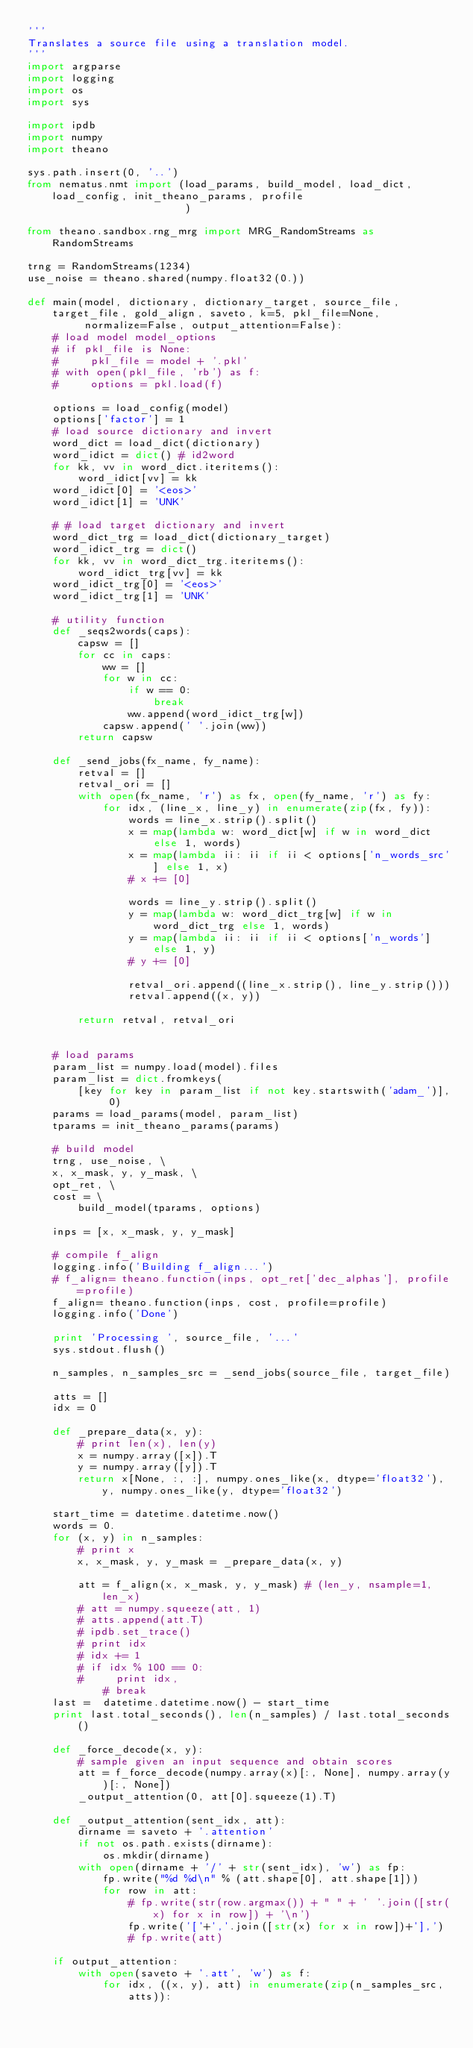Convert code to text. <code><loc_0><loc_0><loc_500><loc_500><_Python_>'''
Translates a source file using a translation model.
'''
import argparse
import logging
import os
import sys

import ipdb
import numpy
import theano

sys.path.insert(0, '..')
from nematus.nmt import (load_params, build_model, load_dict, load_config, init_theano_params, profile
                         )

from theano.sandbox.rng_mrg import MRG_RandomStreams as RandomStreams

trng = RandomStreams(1234)
use_noise = theano.shared(numpy.float32(0.))

def main(model, dictionary, dictionary_target, source_file, target_file, gold_align, saveto, k=5, pkl_file=None,
         normalize=False, output_attention=False):
    # load model model_options
    # if pkl_file is None:
    #     pkl_file = model + '.pkl'
    # with open(pkl_file, 'rb') as f:
    #     options = pkl.load(f)

    options = load_config(model)
    options['factor'] = 1
    # load source dictionary and invert
    word_dict = load_dict(dictionary)
    word_idict = dict() # id2word
    for kk, vv in word_dict.iteritems():
        word_idict[vv] = kk
    word_idict[0] = '<eos>'
    word_idict[1] = 'UNK'

    # # load target dictionary and invert
    word_dict_trg = load_dict(dictionary_target)
    word_idict_trg = dict()
    for kk, vv in word_dict_trg.iteritems():
        word_idict_trg[vv] = kk
    word_idict_trg[0] = '<eos>'
    word_idict_trg[1] = 'UNK'

    # utility function
    def _seqs2words(caps):
        capsw = []
        for cc in caps:
            ww = []
            for w in cc:
                if w == 0:
                    break
                ww.append(word_idict_trg[w])
            capsw.append(' '.join(ww))
        return capsw

    def _send_jobs(fx_name, fy_name):
        retval = []
        retval_ori = []
        with open(fx_name, 'r') as fx, open(fy_name, 'r') as fy:
            for idx, (line_x, line_y) in enumerate(zip(fx, fy)):
                words = line_x.strip().split()
                x = map(lambda w: word_dict[w] if w in word_dict else 1, words)
                x = map(lambda ii: ii if ii < options['n_words_src'] else 1, x)
                # x += [0]

                words = line_y.strip().split()
                y = map(lambda w: word_dict_trg[w] if w in word_dict_trg else 1, words)
                y = map(lambda ii: ii if ii < options['n_words'] else 1, y)
                # y += [0]

                retval_ori.append((line_x.strip(), line_y.strip()))
                retval.append((x, y))

        return retval, retval_ori


    # load params
    param_list = numpy.load(model).files
    param_list = dict.fromkeys(
        [key for key in param_list if not key.startswith('adam_')], 0)
    params = load_params(model, param_list)
    tparams = init_theano_params(params)

    # build model
    trng, use_noise, \
    x, x_mask, y, y_mask, \
    opt_ret, \
    cost = \
        build_model(tparams, options)

    inps = [x, x_mask, y, y_mask]

    # compile f_align
    logging.info('Building f_align...')
    # f_align= theano.function(inps, opt_ret['dec_alphas'], profile=profile)
    f_align= theano.function(inps, cost, profile=profile)
    logging.info('Done')

    print 'Processing ', source_file, '...'
    sys.stdout.flush()

    n_samples, n_samples_src = _send_jobs(source_file, target_file)

    atts = []
    idx = 0

    def _prepare_data(x, y):
        # print len(x), len(y)
        x = numpy.array([x]).T
        y = numpy.array([y]).T
        return x[None, :, :], numpy.ones_like(x, dtype='float32'), y, numpy.ones_like(y, dtype='float32')

    start_time = datetime.datetime.now()
    words = 0.
    for (x, y) in n_samples:
        # print x
        x, x_mask, y, y_mask = _prepare_data(x, y)

        att = f_align(x, x_mask, y, y_mask) # (len_y, nsample=1, len_x)
        # att = numpy.squeeze(att, 1)
        # atts.append(att.T)
        # ipdb.set_trace()
        # print idx
        # idx += 1
        # if idx % 100 == 0:
        #     print idx,
            # break
    last =  datetime.datetime.now() - start_time
    print last.total_seconds(), len(n_samples) / last.total_seconds()

    def _force_decode(x, y):
        # sample given an input sequence and obtain scores
        att = f_force_decode(numpy.array(x)[:, None], numpy.array(y)[:, None])
        _output_attention(0, att[0].squeeze(1).T)

    def _output_attention(sent_idx, att):
        dirname = saveto + '.attention'
        if not os.path.exists(dirname):
            os.mkdir(dirname)
        with open(dirname + '/' + str(sent_idx), 'w') as fp:
            fp.write("%d %d\n" % (att.shape[0], att.shape[1]))
            for row in att:
                # fp.write(str(row.argmax()) + " " + ' '.join([str(x) for x in row]) + '\n')
                fp.write('['+','.join([str(x) for x in row])+'],')
                # fp.write(att)

    if output_attention:
        with open(saveto + '.att', 'w') as f:
            for idx, ((x, y), att) in enumerate(zip(n_samples_src, atts)):</code> 